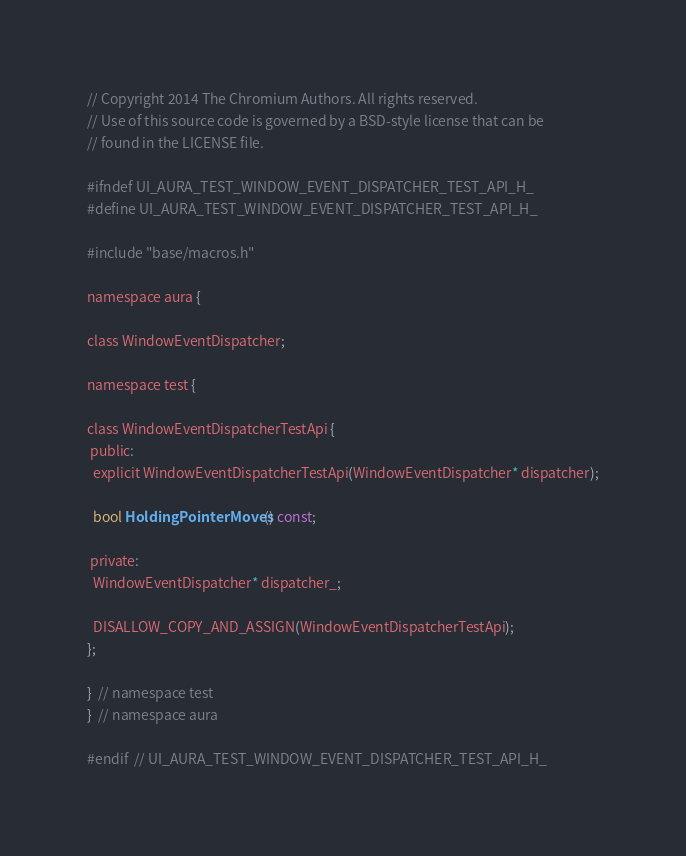Convert code to text. <code><loc_0><loc_0><loc_500><loc_500><_C_>// Copyright 2014 The Chromium Authors. All rights reserved.
// Use of this source code is governed by a BSD-style license that can be
// found in the LICENSE file.

#ifndef UI_AURA_TEST_WINDOW_EVENT_DISPATCHER_TEST_API_H_
#define UI_AURA_TEST_WINDOW_EVENT_DISPATCHER_TEST_API_H_

#include "base/macros.h"

namespace aura {

class WindowEventDispatcher;

namespace test {

class WindowEventDispatcherTestApi {
 public:
  explicit WindowEventDispatcherTestApi(WindowEventDispatcher* dispatcher);

  bool HoldingPointerMoves() const;

 private:
  WindowEventDispatcher* dispatcher_;

  DISALLOW_COPY_AND_ASSIGN(WindowEventDispatcherTestApi);
};

}  // namespace test
}  // namespace aura

#endif  // UI_AURA_TEST_WINDOW_EVENT_DISPATCHER_TEST_API_H_
</code> 